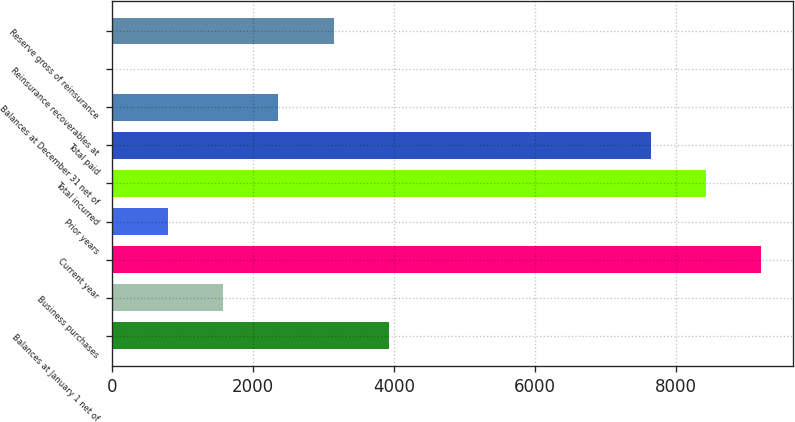<chart> <loc_0><loc_0><loc_500><loc_500><bar_chart><fcel>Balances at January 1 net of<fcel>Business purchases<fcel>Current year<fcel>Prior years<fcel>Total incurred<fcel>Total paid<fcel>Balances at December 31 net of<fcel>Reinsurance recoverables at<fcel>Reserve gross of reinsurance<nl><fcel>3925.35<fcel>1574.7<fcel>9204.1<fcel>791.15<fcel>8420.55<fcel>7637<fcel>2358.25<fcel>7.6<fcel>3141.8<nl></chart> 